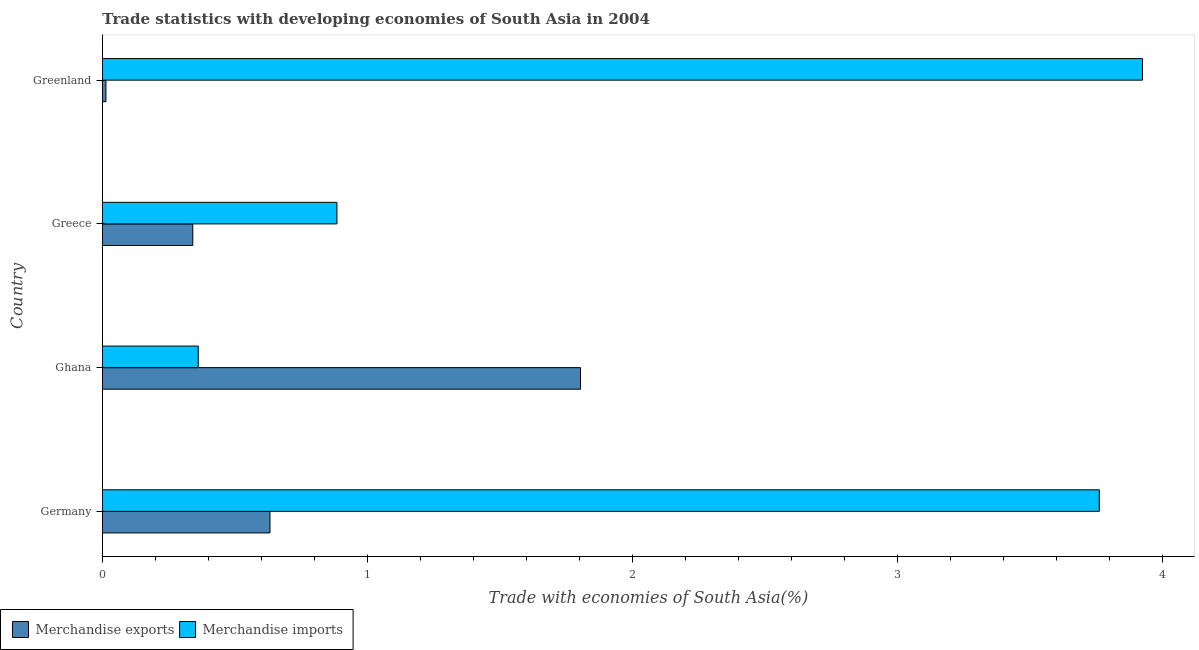How many bars are there on the 3rd tick from the top?
Ensure brevity in your answer.  2. What is the label of the 1st group of bars from the top?
Offer a terse response. Greenland. In how many cases, is the number of bars for a given country not equal to the number of legend labels?
Keep it short and to the point. 0. What is the merchandise imports in Germany?
Provide a short and direct response. 3.76. Across all countries, what is the maximum merchandise imports?
Your answer should be very brief. 3.92. Across all countries, what is the minimum merchandise exports?
Ensure brevity in your answer.  0.01. In which country was the merchandise imports maximum?
Give a very brief answer. Greenland. In which country was the merchandise exports minimum?
Provide a succinct answer. Greenland. What is the total merchandise exports in the graph?
Your answer should be very brief. 2.79. What is the difference between the merchandise exports in Germany and that in Ghana?
Offer a terse response. -1.17. What is the difference between the merchandise exports in Greece and the merchandise imports in Greenland?
Provide a succinct answer. -3.58. What is the average merchandise exports per country?
Keep it short and to the point. 0.7. What is the difference between the merchandise exports and merchandise imports in Greece?
Provide a short and direct response. -0.54. What is the ratio of the merchandise exports in Ghana to that in Greenland?
Ensure brevity in your answer.  136.96. Is the merchandise imports in Greece less than that in Greenland?
Your answer should be compact. Yes. What is the difference between the highest and the second highest merchandise imports?
Your answer should be very brief. 0.16. What is the difference between the highest and the lowest merchandise imports?
Provide a succinct answer. 3.56. In how many countries, is the merchandise exports greater than the average merchandise exports taken over all countries?
Your answer should be very brief. 1. Is the sum of the merchandise imports in Greece and Greenland greater than the maximum merchandise exports across all countries?
Your response must be concise. Yes. What does the 1st bar from the bottom in Germany represents?
Offer a terse response. Merchandise exports. How many bars are there?
Your answer should be very brief. 8. How many countries are there in the graph?
Your answer should be very brief. 4. What is the difference between two consecutive major ticks on the X-axis?
Your answer should be compact. 1. Are the values on the major ticks of X-axis written in scientific E-notation?
Your answer should be compact. No. Does the graph contain grids?
Make the answer very short. No. How many legend labels are there?
Provide a short and direct response. 2. How are the legend labels stacked?
Your answer should be compact. Horizontal. What is the title of the graph?
Ensure brevity in your answer.  Trade statistics with developing economies of South Asia in 2004. What is the label or title of the X-axis?
Give a very brief answer. Trade with economies of South Asia(%). What is the Trade with economies of South Asia(%) in Merchandise exports in Germany?
Your response must be concise. 0.63. What is the Trade with economies of South Asia(%) of Merchandise imports in Germany?
Ensure brevity in your answer.  3.76. What is the Trade with economies of South Asia(%) of Merchandise exports in Ghana?
Keep it short and to the point. 1.8. What is the Trade with economies of South Asia(%) of Merchandise imports in Ghana?
Your answer should be very brief. 0.36. What is the Trade with economies of South Asia(%) of Merchandise exports in Greece?
Give a very brief answer. 0.34. What is the Trade with economies of South Asia(%) of Merchandise imports in Greece?
Provide a short and direct response. 0.88. What is the Trade with economies of South Asia(%) of Merchandise exports in Greenland?
Offer a terse response. 0.01. What is the Trade with economies of South Asia(%) in Merchandise imports in Greenland?
Offer a very short reply. 3.92. Across all countries, what is the maximum Trade with economies of South Asia(%) in Merchandise exports?
Offer a terse response. 1.8. Across all countries, what is the maximum Trade with economies of South Asia(%) of Merchandise imports?
Keep it short and to the point. 3.92. Across all countries, what is the minimum Trade with economies of South Asia(%) in Merchandise exports?
Provide a succinct answer. 0.01. Across all countries, what is the minimum Trade with economies of South Asia(%) in Merchandise imports?
Provide a short and direct response. 0.36. What is the total Trade with economies of South Asia(%) in Merchandise exports in the graph?
Ensure brevity in your answer.  2.79. What is the total Trade with economies of South Asia(%) in Merchandise imports in the graph?
Ensure brevity in your answer.  8.93. What is the difference between the Trade with economies of South Asia(%) in Merchandise exports in Germany and that in Ghana?
Ensure brevity in your answer.  -1.17. What is the difference between the Trade with economies of South Asia(%) in Merchandise imports in Germany and that in Ghana?
Offer a very short reply. 3.4. What is the difference between the Trade with economies of South Asia(%) in Merchandise exports in Germany and that in Greece?
Your answer should be very brief. 0.29. What is the difference between the Trade with economies of South Asia(%) of Merchandise imports in Germany and that in Greece?
Offer a very short reply. 2.88. What is the difference between the Trade with economies of South Asia(%) in Merchandise exports in Germany and that in Greenland?
Give a very brief answer. 0.62. What is the difference between the Trade with economies of South Asia(%) of Merchandise imports in Germany and that in Greenland?
Offer a terse response. -0.16. What is the difference between the Trade with economies of South Asia(%) of Merchandise exports in Ghana and that in Greece?
Your answer should be compact. 1.46. What is the difference between the Trade with economies of South Asia(%) of Merchandise imports in Ghana and that in Greece?
Give a very brief answer. -0.52. What is the difference between the Trade with economies of South Asia(%) in Merchandise exports in Ghana and that in Greenland?
Provide a succinct answer. 1.79. What is the difference between the Trade with economies of South Asia(%) of Merchandise imports in Ghana and that in Greenland?
Provide a succinct answer. -3.56. What is the difference between the Trade with economies of South Asia(%) in Merchandise exports in Greece and that in Greenland?
Provide a succinct answer. 0.33. What is the difference between the Trade with economies of South Asia(%) in Merchandise imports in Greece and that in Greenland?
Provide a short and direct response. -3.04. What is the difference between the Trade with economies of South Asia(%) of Merchandise exports in Germany and the Trade with economies of South Asia(%) of Merchandise imports in Ghana?
Keep it short and to the point. 0.27. What is the difference between the Trade with economies of South Asia(%) of Merchandise exports in Germany and the Trade with economies of South Asia(%) of Merchandise imports in Greece?
Make the answer very short. -0.25. What is the difference between the Trade with economies of South Asia(%) in Merchandise exports in Germany and the Trade with economies of South Asia(%) in Merchandise imports in Greenland?
Offer a very short reply. -3.29. What is the difference between the Trade with economies of South Asia(%) of Merchandise exports in Ghana and the Trade with economies of South Asia(%) of Merchandise imports in Greece?
Make the answer very short. 0.92. What is the difference between the Trade with economies of South Asia(%) in Merchandise exports in Ghana and the Trade with economies of South Asia(%) in Merchandise imports in Greenland?
Provide a succinct answer. -2.12. What is the difference between the Trade with economies of South Asia(%) of Merchandise exports in Greece and the Trade with economies of South Asia(%) of Merchandise imports in Greenland?
Your response must be concise. -3.58. What is the average Trade with economies of South Asia(%) of Merchandise exports per country?
Your response must be concise. 0.7. What is the average Trade with economies of South Asia(%) in Merchandise imports per country?
Give a very brief answer. 2.23. What is the difference between the Trade with economies of South Asia(%) in Merchandise exports and Trade with economies of South Asia(%) in Merchandise imports in Germany?
Offer a very short reply. -3.13. What is the difference between the Trade with economies of South Asia(%) of Merchandise exports and Trade with economies of South Asia(%) of Merchandise imports in Ghana?
Provide a short and direct response. 1.44. What is the difference between the Trade with economies of South Asia(%) of Merchandise exports and Trade with economies of South Asia(%) of Merchandise imports in Greece?
Make the answer very short. -0.54. What is the difference between the Trade with economies of South Asia(%) in Merchandise exports and Trade with economies of South Asia(%) in Merchandise imports in Greenland?
Your answer should be compact. -3.91. What is the ratio of the Trade with economies of South Asia(%) of Merchandise exports in Germany to that in Ghana?
Your response must be concise. 0.35. What is the ratio of the Trade with economies of South Asia(%) of Merchandise imports in Germany to that in Ghana?
Keep it short and to the point. 10.41. What is the ratio of the Trade with economies of South Asia(%) of Merchandise exports in Germany to that in Greece?
Your response must be concise. 1.85. What is the ratio of the Trade with economies of South Asia(%) in Merchandise imports in Germany to that in Greece?
Offer a terse response. 4.25. What is the ratio of the Trade with economies of South Asia(%) of Merchandise exports in Germany to that in Greenland?
Give a very brief answer. 48. What is the ratio of the Trade with economies of South Asia(%) in Merchandise imports in Germany to that in Greenland?
Offer a terse response. 0.96. What is the ratio of the Trade with economies of South Asia(%) of Merchandise exports in Ghana to that in Greece?
Your response must be concise. 5.29. What is the ratio of the Trade with economies of South Asia(%) of Merchandise imports in Ghana to that in Greece?
Keep it short and to the point. 0.41. What is the ratio of the Trade with economies of South Asia(%) in Merchandise exports in Ghana to that in Greenland?
Offer a terse response. 136.96. What is the ratio of the Trade with economies of South Asia(%) in Merchandise imports in Ghana to that in Greenland?
Keep it short and to the point. 0.09. What is the ratio of the Trade with economies of South Asia(%) of Merchandise exports in Greece to that in Greenland?
Offer a terse response. 25.88. What is the ratio of the Trade with economies of South Asia(%) of Merchandise imports in Greece to that in Greenland?
Offer a very short reply. 0.23. What is the difference between the highest and the second highest Trade with economies of South Asia(%) in Merchandise exports?
Offer a very short reply. 1.17. What is the difference between the highest and the second highest Trade with economies of South Asia(%) of Merchandise imports?
Your answer should be compact. 0.16. What is the difference between the highest and the lowest Trade with economies of South Asia(%) of Merchandise exports?
Provide a short and direct response. 1.79. What is the difference between the highest and the lowest Trade with economies of South Asia(%) in Merchandise imports?
Provide a succinct answer. 3.56. 